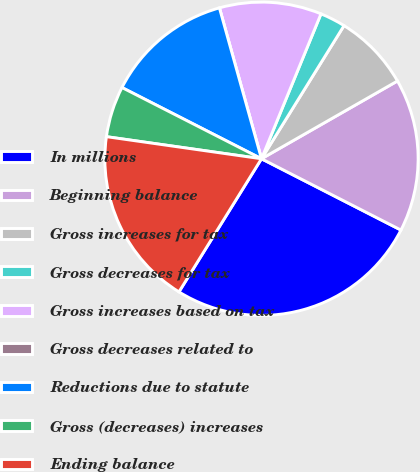Convert chart. <chart><loc_0><loc_0><loc_500><loc_500><pie_chart><fcel>In millions<fcel>Beginning balance<fcel>Gross increases for tax<fcel>Gross decreases for tax<fcel>Gross increases based on tax<fcel>Gross decreases related to<fcel>Reductions due to statute<fcel>Gross (decreases) increases<fcel>Ending balance<nl><fcel>26.31%<fcel>15.79%<fcel>7.9%<fcel>2.63%<fcel>10.53%<fcel>0.0%<fcel>13.16%<fcel>5.26%<fcel>18.42%<nl></chart> 